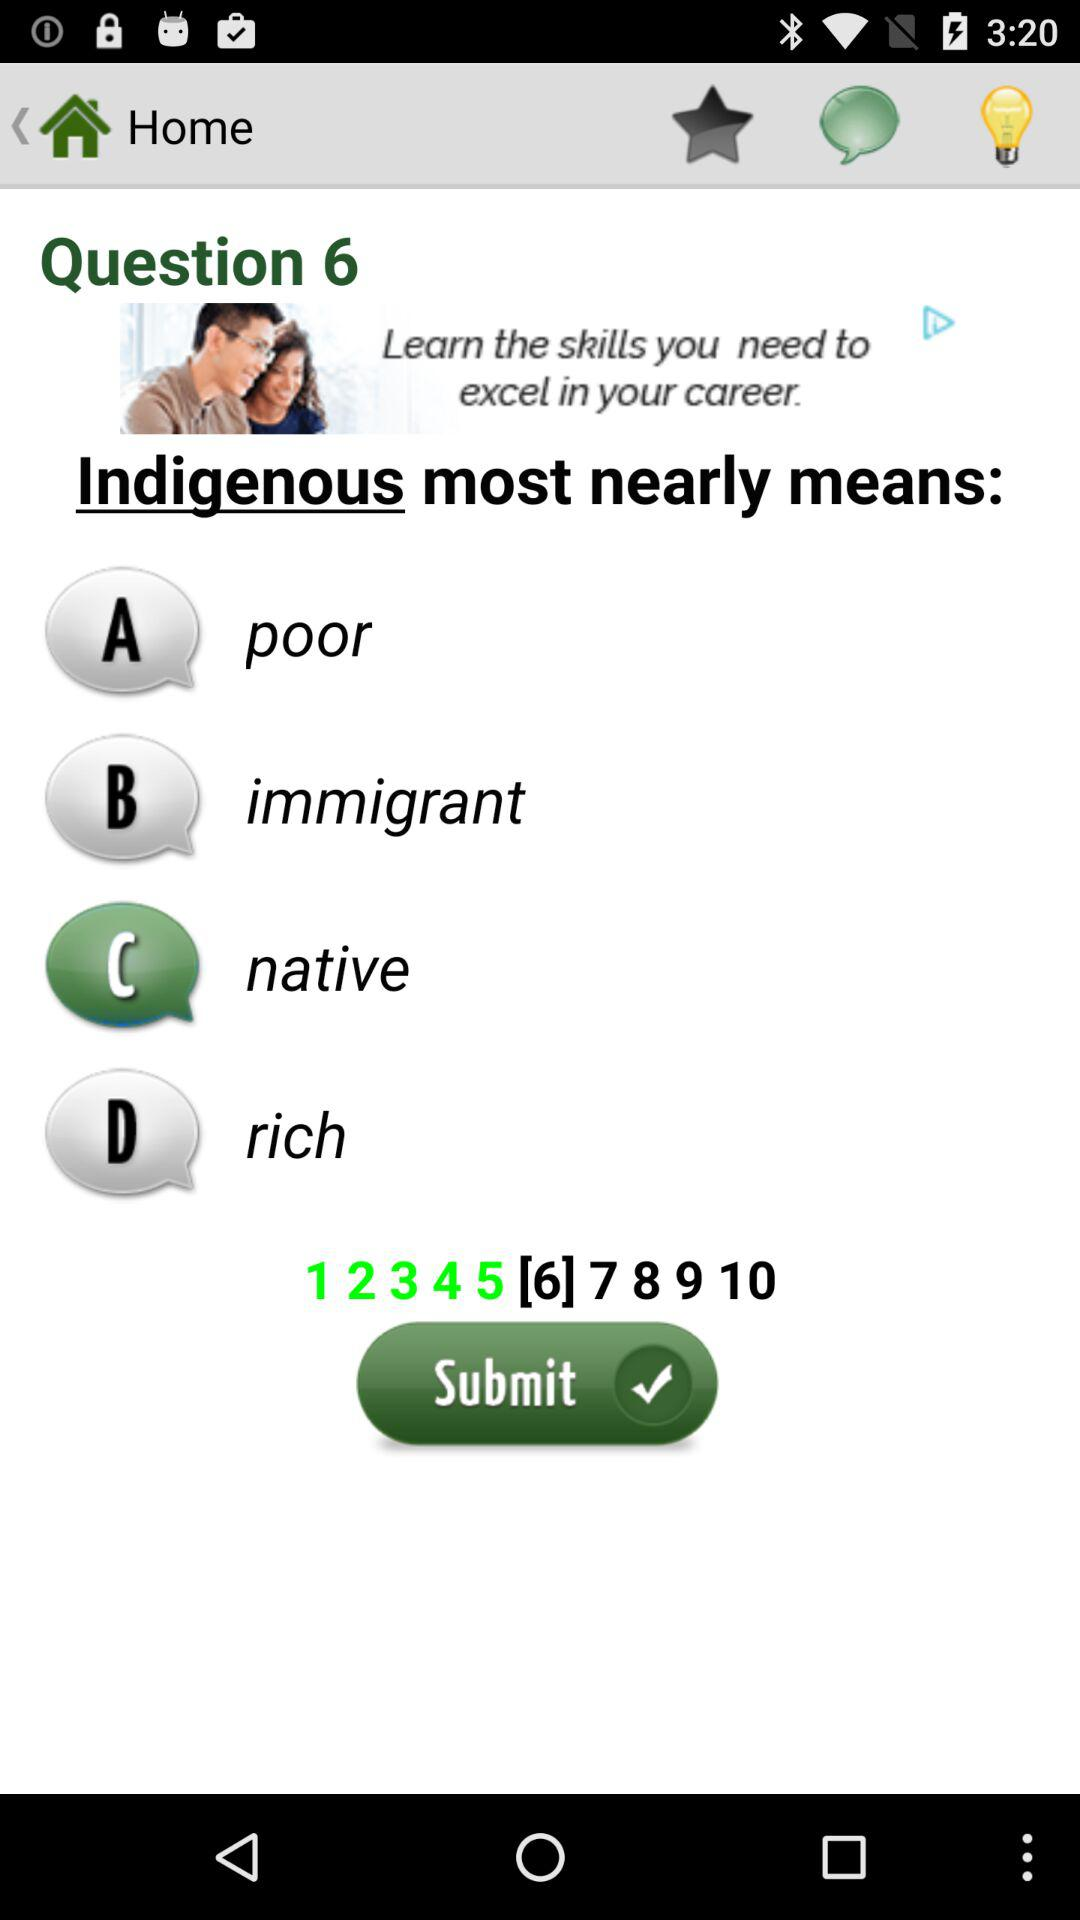What is the number of current question? The number of current question is 6. 